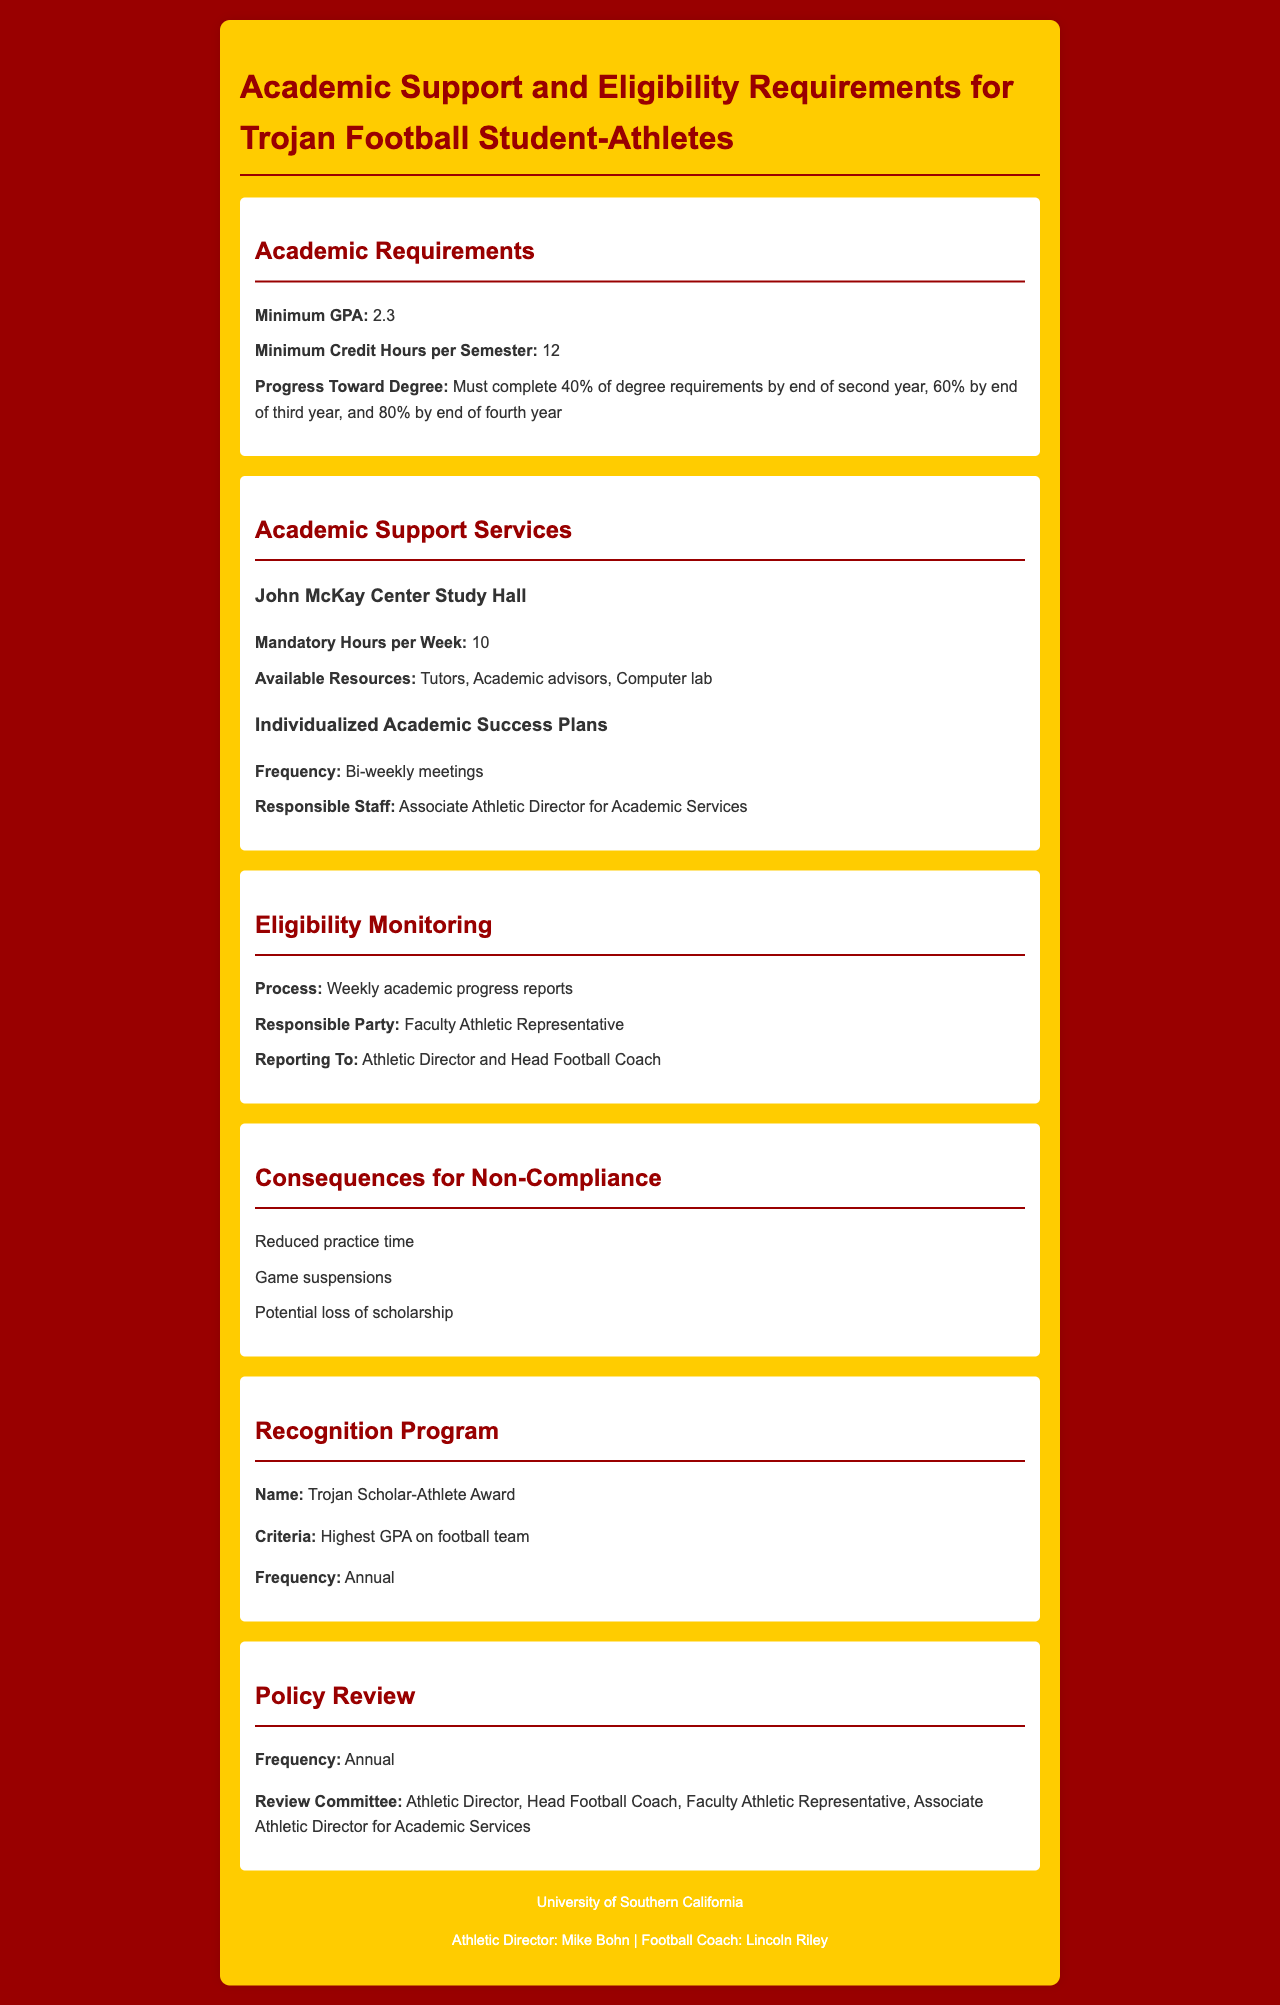What is the minimum GPA required for student-athletes? The document specifies that the minimum GPA required is 2.3.
Answer: 2.3 How many credit hours must student-athletes complete per semester? It states that the minimum credit hours per semester required is 12.
Answer: 12 How often are individualized academic success plans reviewed? The document mentions that these plans include bi-weekly meetings.
Answer: Bi-weekly What is the name of the academic support center mentioned? The document refers to the academic support center as the John McKay Center.
Answer: John McKay Center What consequence is listed for non-compliance regarding academic requirements? One of the consequences for non-compliance mentioned is reduced practice time.
Answer: Reduced practice time What must student-athletes complete by the end of their third year? They must complete 60% of degree requirements by the end of their third year.
Answer: 60% Who is responsible for monitoring eligibility? The document indicates that the Faculty Athletic Representative is responsible for eligibility monitoring.
Answer: Faculty Athletic Representative What is the name of the recognition program for top-performing student-athletes? The document names the recognition program as the Trojan Scholar-Athlete Award.
Answer: Trojan Scholar-Athlete Award 